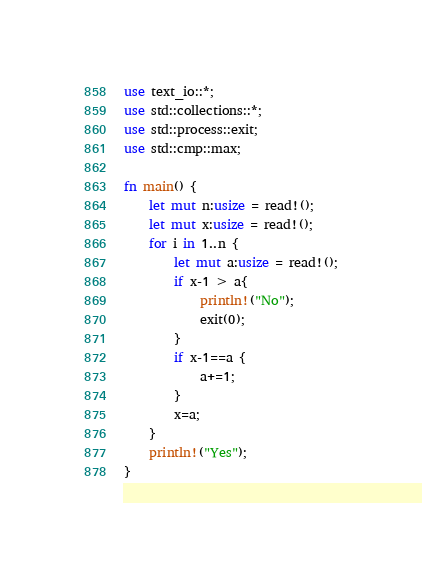<code> <loc_0><loc_0><loc_500><loc_500><_Rust_>use text_io::*;
use std::collections::*;
use std::process::exit;
use std::cmp::max;

fn main() {
    let mut n:usize = read!();
    let mut x:usize = read!();
    for i in 1..n {
        let mut a:usize = read!();
        if x-1 > a{
            println!("No");
            exit(0);
        }
        if x-1==a {
            a+=1;
        }
        x=a;
    }
    println!("Yes");
}</code> 